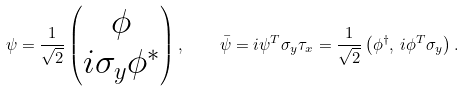<formula> <loc_0><loc_0><loc_500><loc_500>\psi = \frac { 1 } { \sqrt { 2 } } \begin{pmatrix} \phi \\ i \sigma _ { y } \phi ^ { * } \end{pmatrix} , \quad \bar { \psi } = i \psi ^ { T } \sigma _ { y } \tau _ { x } = \frac { 1 } { \sqrt { 2 } } \left ( \phi ^ { \dagger } , \, i \phi ^ { T } \sigma _ { y } \right ) .</formula> 